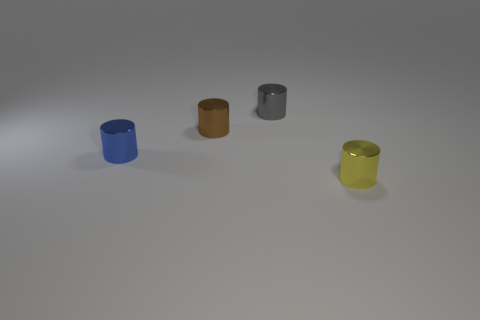What's the texture of the surface these objects are standing on? The surface appears smooth and has a matte finish, with no reflections to suggest it is shiny or textured. 